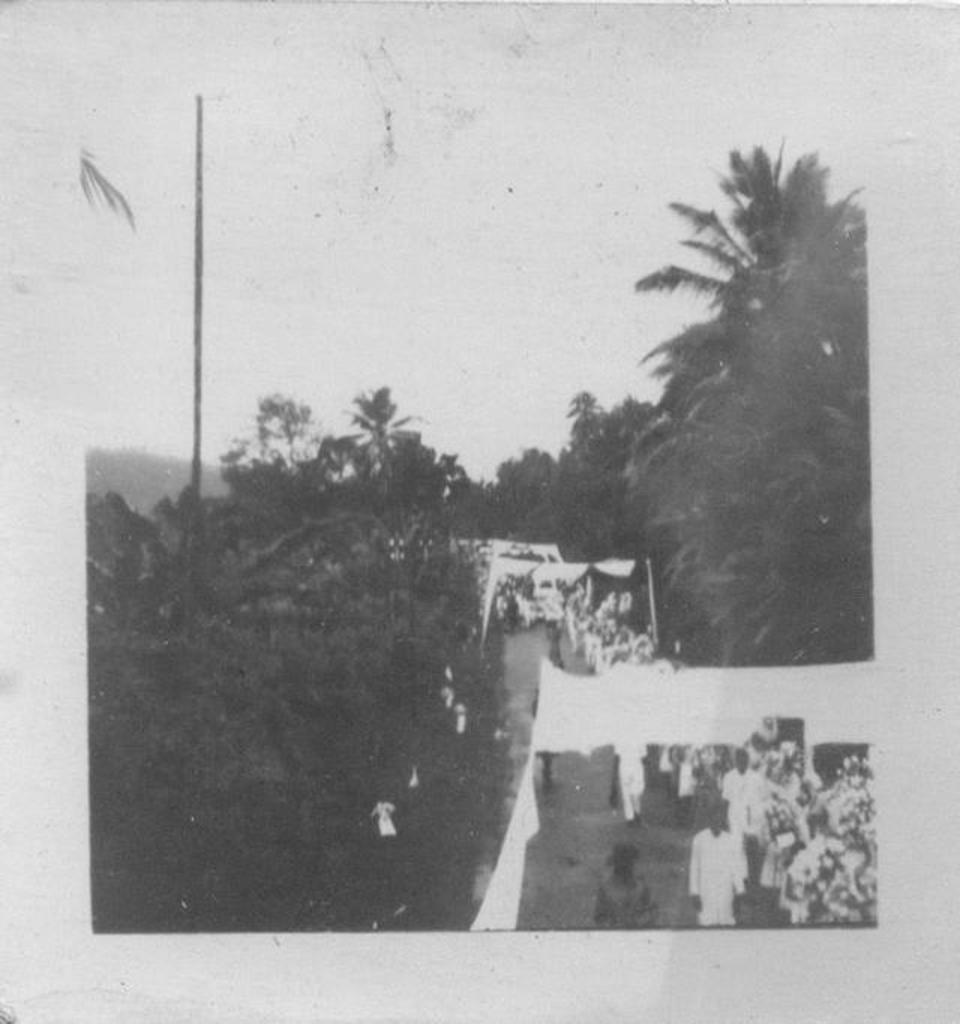What is the color scheme of the image? The image is black and white. Who or what can be seen in the image? There are people in the image. What other objects or elements are present in the image? There are trees and arches made with clothes in the image. What can be seen in the background of the image? The sky is visible in the background of the image. What does the sister regret in the image? There is no mention of a sister or any regret in the image. The image only features people, trees, arches made with clothes, and a black and white color scheme. 